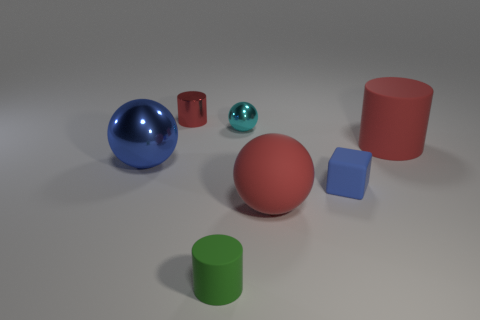Subtract all brown spheres. How many red cylinders are left? 2 Subtract 1 cylinders. How many cylinders are left? 2 Add 2 small metallic objects. How many objects exist? 9 Subtract all cylinders. How many objects are left? 4 Subtract 0 gray cylinders. How many objects are left? 7 Subtract all big purple rubber cubes. Subtract all small blue blocks. How many objects are left? 6 Add 3 red rubber things. How many red rubber things are left? 5 Add 6 red metallic balls. How many red metallic balls exist? 6 